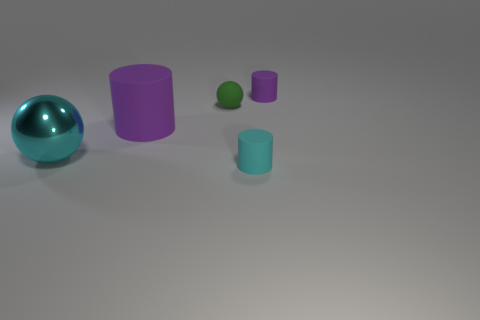Add 3 big purple rubber cylinders. How many objects exist? 8 Subtract all cylinders. How many objects are left? 2 Add 5 cyan metal objects. How many cyan metal objects are left? 6 Add 3 cyan shiny cylinders. How many cyan shiny cylinders exist? 3 Subtract 0 gray spheres. How many objects are left? 5 Subtract all large gray shiny balls. Subtract all small purple objects. How many objects are left? 4 